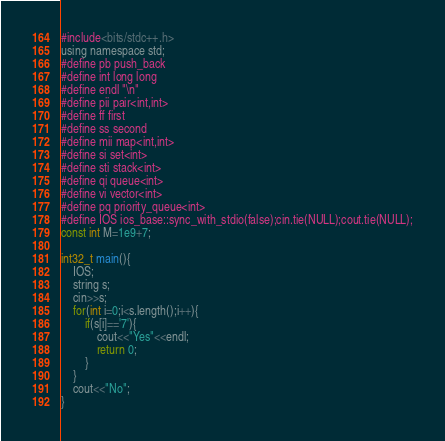<code> <loc_0><loc_0><loc_500><loc_500><_C_>#include<bits/stdc++.h>
using namespace std;
#define pb push_back
#define int long long
#define endl "\n"
#define pii pair<int,int> 
#define ff first
#define ss second
#define mii map<int,int>
#define si set<int>
#define sti stack<int>
#define qi queue<int>
#define vi vector<int>
#define pq priority_queue<int>
#define IOS ios_base::sync_with_stdio(false);cin.tie(NULL);cout.tie(NULL);
const int M=1e9+7;

int32_t main(){
    IOS;
    string s;
    cin>>s;
    for(int i=0;i<s.length();i++){
        if(s[i]=='7'){
            cout<<"Yes"<<endl;
            return 0;
        }
    }
    cout<<"No";
}</code> 